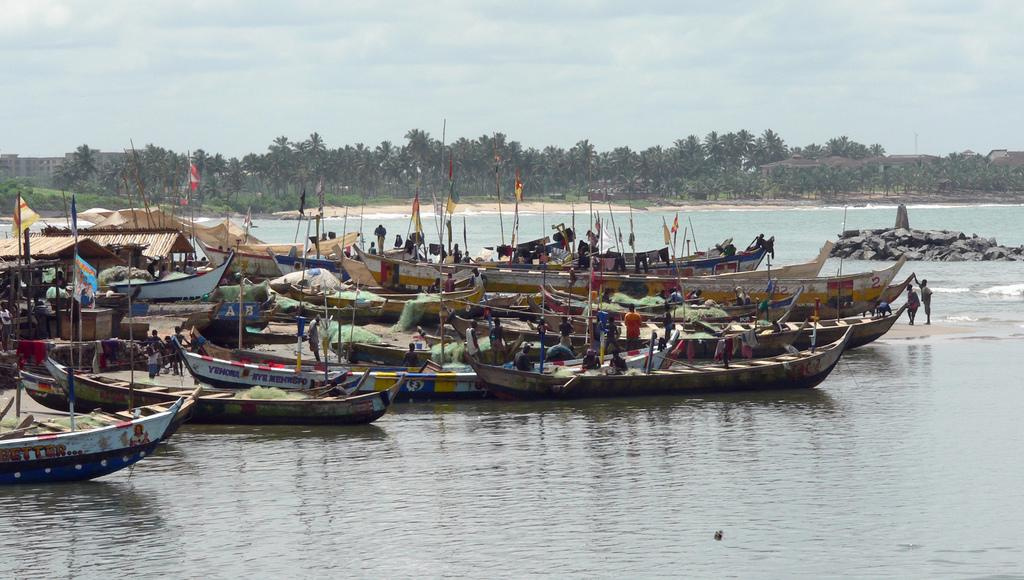What can be seen in the image? There are people, boats, sheds, flags, rocks, and poles in the image. What is visible in the background of the image? There are trees, houses, and the sky visible in the background of the image. How many types of structures are present in the image? There are sheds, flags, rocks, and poles in the image, making a total of four types of structures. What type of transport is being used by the people in the image? There is no specific transport mentioned or visible in the image; the people are likely on foot or standing near the boats. Can you tell me how many hoses are present in the image? There are no hoses present in the image. 